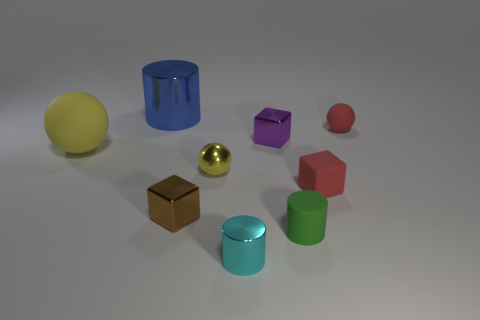Subtract all large yellow spheres. How many spheres are left? 2 Subtract all blue cylinders. How many cylinders are left? 2 Add 1 green rubber cylinders. How many objects exist? 10 Subtract all cyan cubes. How many gray spheres are left? 0 Subtract all spheres. How many objects are left? 6 Subtract 2 cubes. How many cubes are left? 1 Subtract all cyan cylinders. Subtract all red spheres. How many cylinders are left? 2 Subtract all small yellow objects. Subtract all big shiny cylinders. How many objects are left? 7 Add 9 metal balls. How many metal balls are left? 10 Add 5 large purple metallic cubes. How many large purple metallic cubes exist? 5 